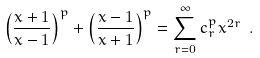Convert formula to latex. <formula><loc_0><loc_0><loc_500><loc_500>\left ( \frac { x + 1 } { x - 1 } \right ) ^ { p } + \left ( \frac { x - 1 } { x + 1 } \right ) ^ { p } = \sum _ { r = 0 } ^ { \infty } c _ { r } ^ { p } x ^ { 2 r } \ .</formula> 